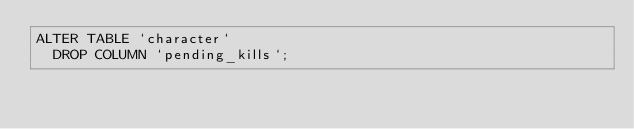<code> <loc_0><loc_0><loc_500><loc_500><_SQL_>ALTER TABLE `character`
  DROP COLUMN `pending_kills`;
</code> 